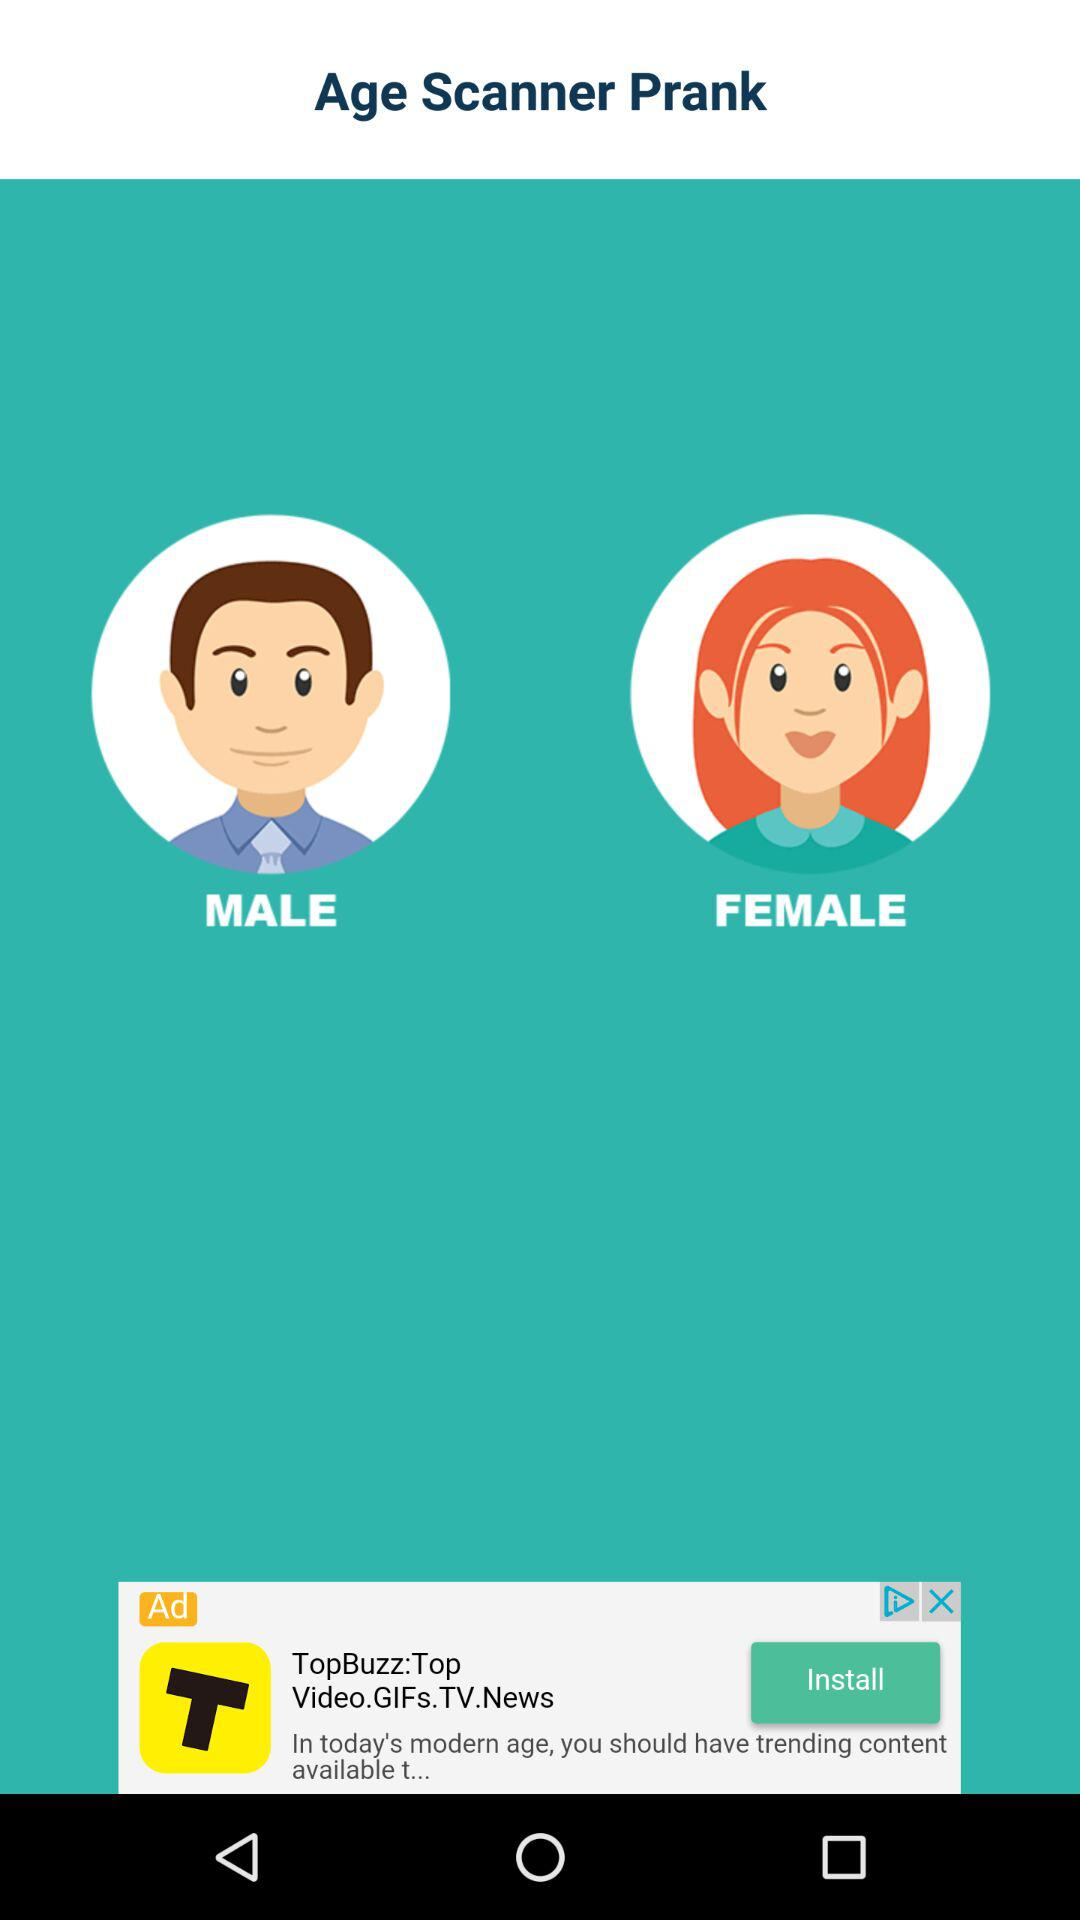What is the app name? The app name is "Age Scanner Prank". 